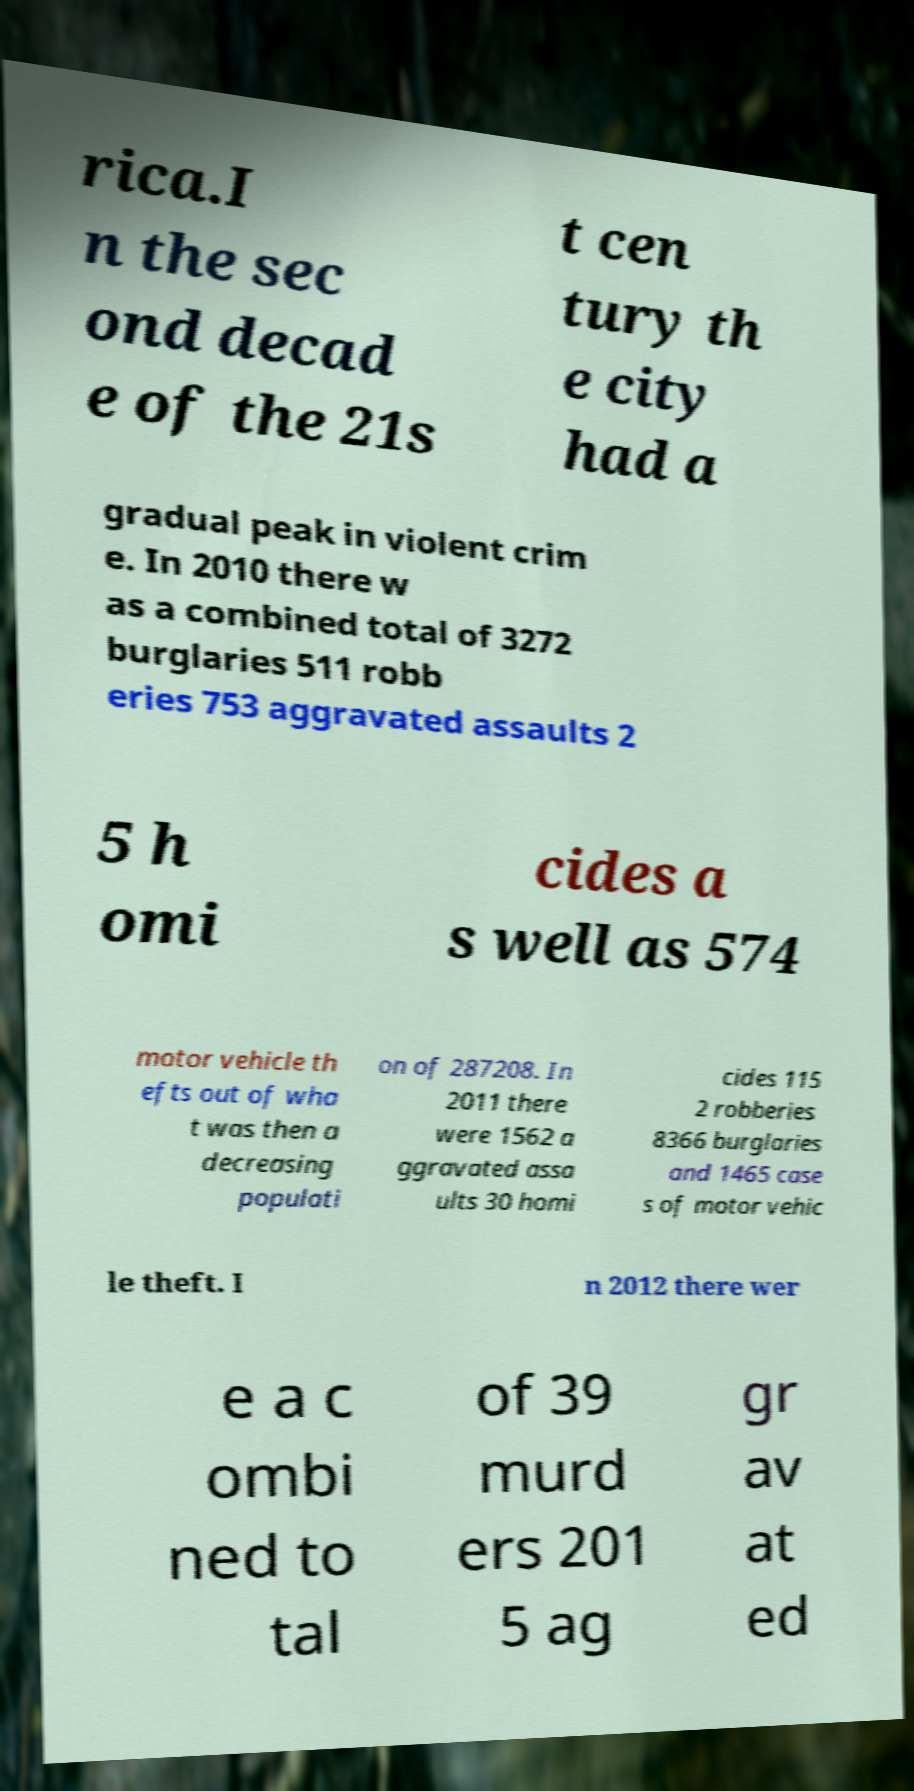What messages or text are displayed in this image? I need them in a readable, typed format. rica.I n the sec ond decad e of the 21s t cen tury th e city had a gradual peak in violent crim e. In 2010 there w as a combined total of 3272 burglaries 511 robb eries 753 aggravated assaults 2 5 h omi cides a s well as 574 motor vehicle th efts out of wha t was then a decreasing populati on of 287208. In 2011 there were 1562 a ggravated assa ults 30 homi cides 115 2 robberies 8366 burglaries and 1465 case s of motor vehic le theft. I n 2012 there wer e a c ombi ned to tal of 39 murd ers 201 5 ag gr av at ed 